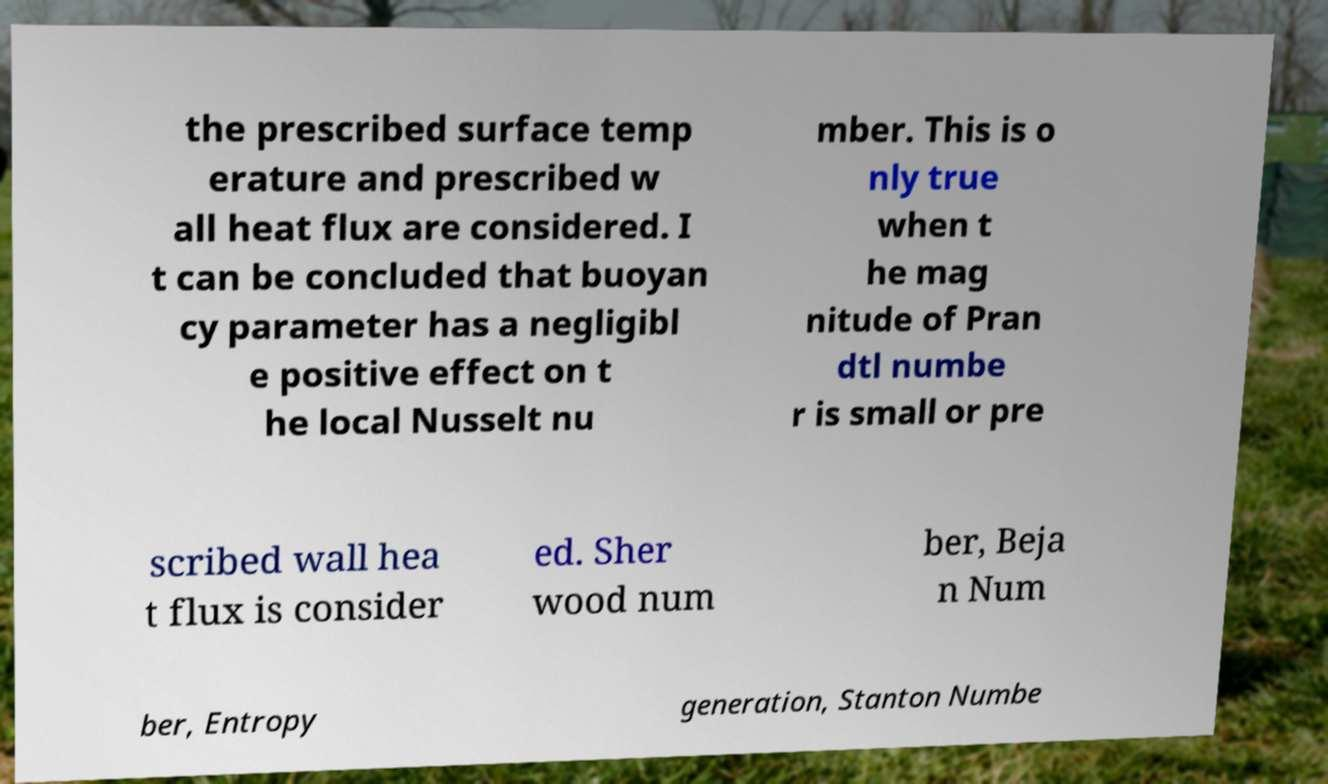Please identify and transcribe the text found in this image. the prescribed surface temp erature and prescribed w all heat flux are considered. I t can be concluded that buoyan cy parameter has a negligibl e positive effect on t he local Nusselt nu mber. This is o nly true when t he mag nitude of Pran dtl numbe r is small or pre scribed wall hea t flux is consider ed. Sher wood num ber, Beja n Num ber, Entropy generation, Stanton Numbe 